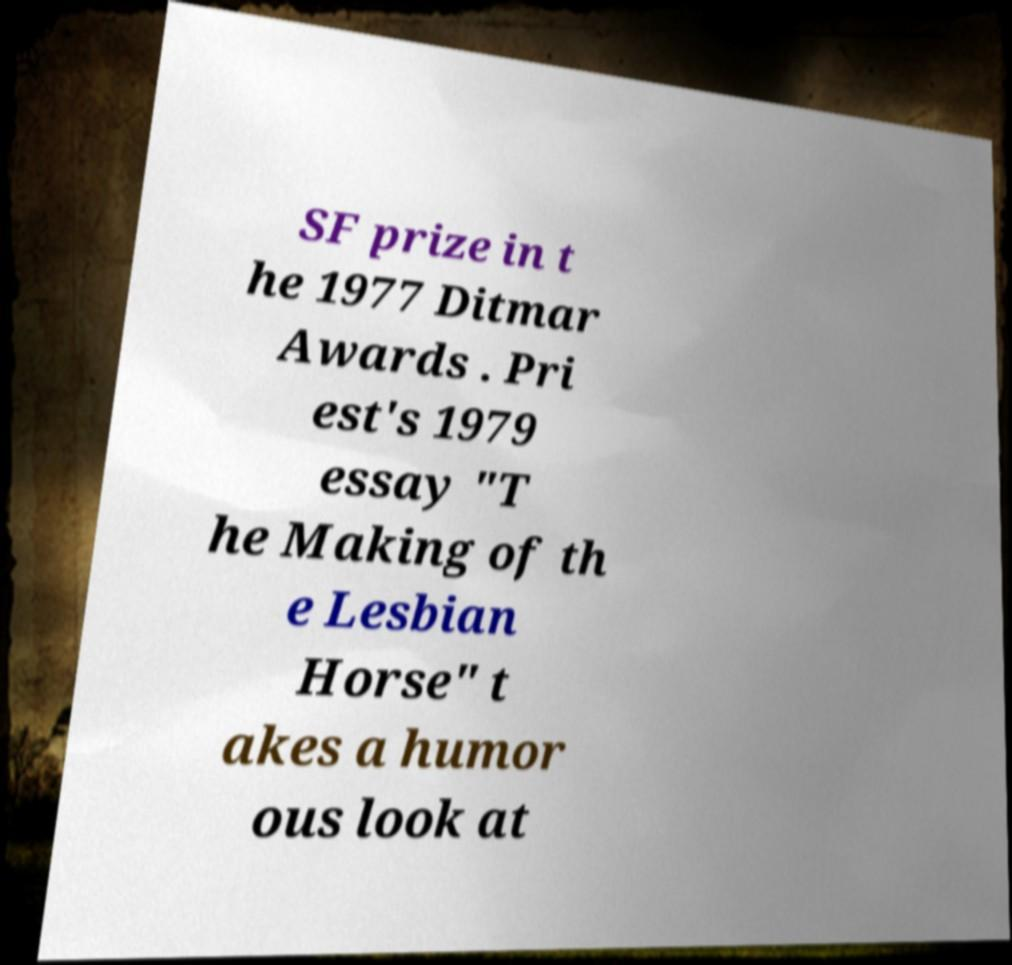Can you accurately transcribe the text from the provided image for me? SF prize in t he 1977 Ditmar Awards . Pri est's 1979 essay "T he Making of th e Lesbian Horse" t akes a humor ous look at 